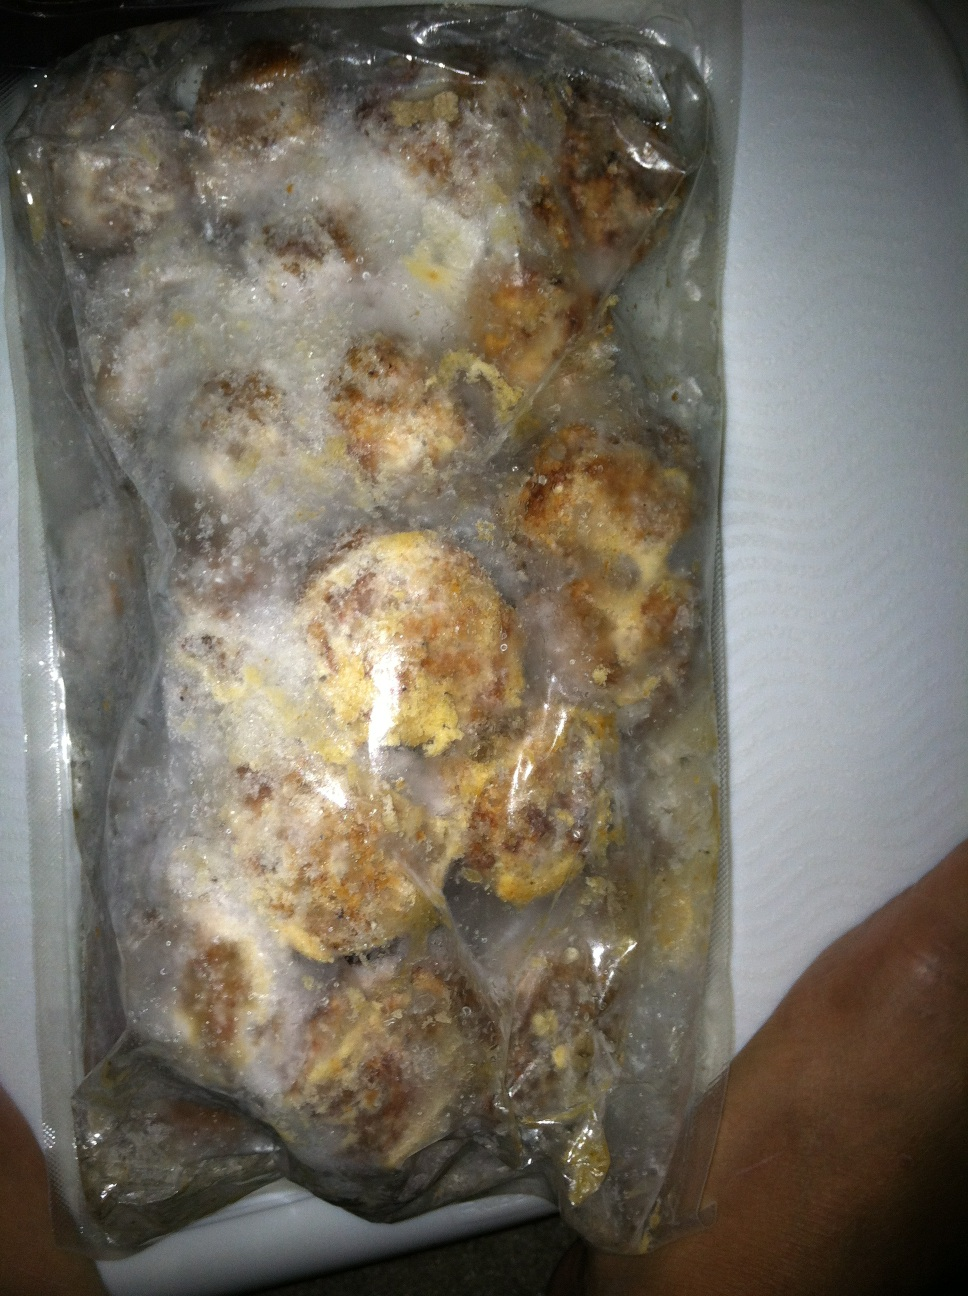What might this frozen package be used for? This frozen package might be used to prepare a quick meal. The frozen meatballs can be reheated or cooked as part of a dish like spaghetti and meatballs, or they could be served as an appetizer or part of a meatball sub sandwich. 